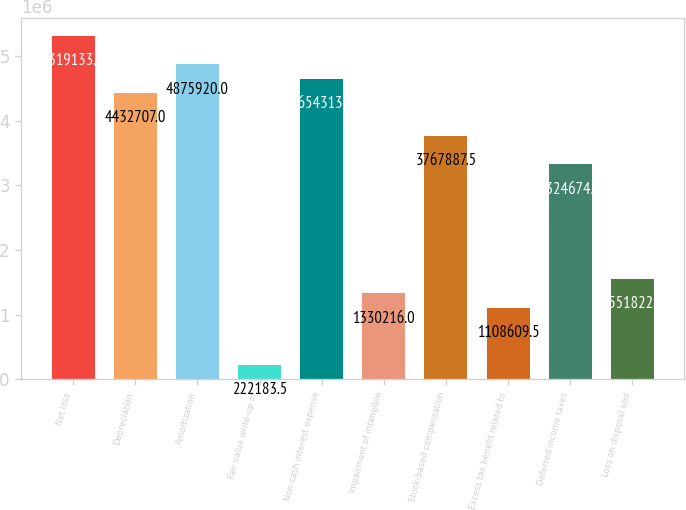Convert chart to OTSL. <chart><loc_0><loc_0><loc_500><loc_500><bar_chart><fcel>Net loss<fcel>Depreciation<fcel>Amortization<fcel>Fair value write-up of<fcel>Non-cash interest expense<fcel>Impairment of intangible<fcel>Stock-based compensation<fcel>Excess tax benefit related to<fcel>Deferred income taxes<fcel>Loss on disposal and<nl><fcel>5.31913e+06<fcel>4.43271e+06<fcel>4.87592e+06<fcel>222184<fcel>4.65431e+06<fcel>1.33022e+06<fcel>3.76789e+06<fcel>1.10861e+06<fcel>3.32467e+06<fcel>1.55182e+06<nl></chart> 